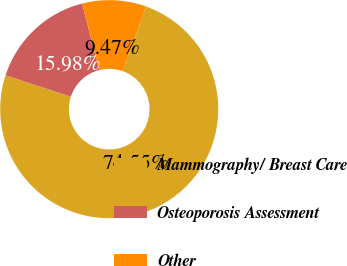<chart> <loc_0><loc_0><loc_500><loc_500><pie_chart><fcel>Mammography/ Breast Care<fcel>Osteoporosis Assessment<fcel>Other<nl><fcel>74.56%<fcel>15.98%<fcel>9.47%<nl></chart> 